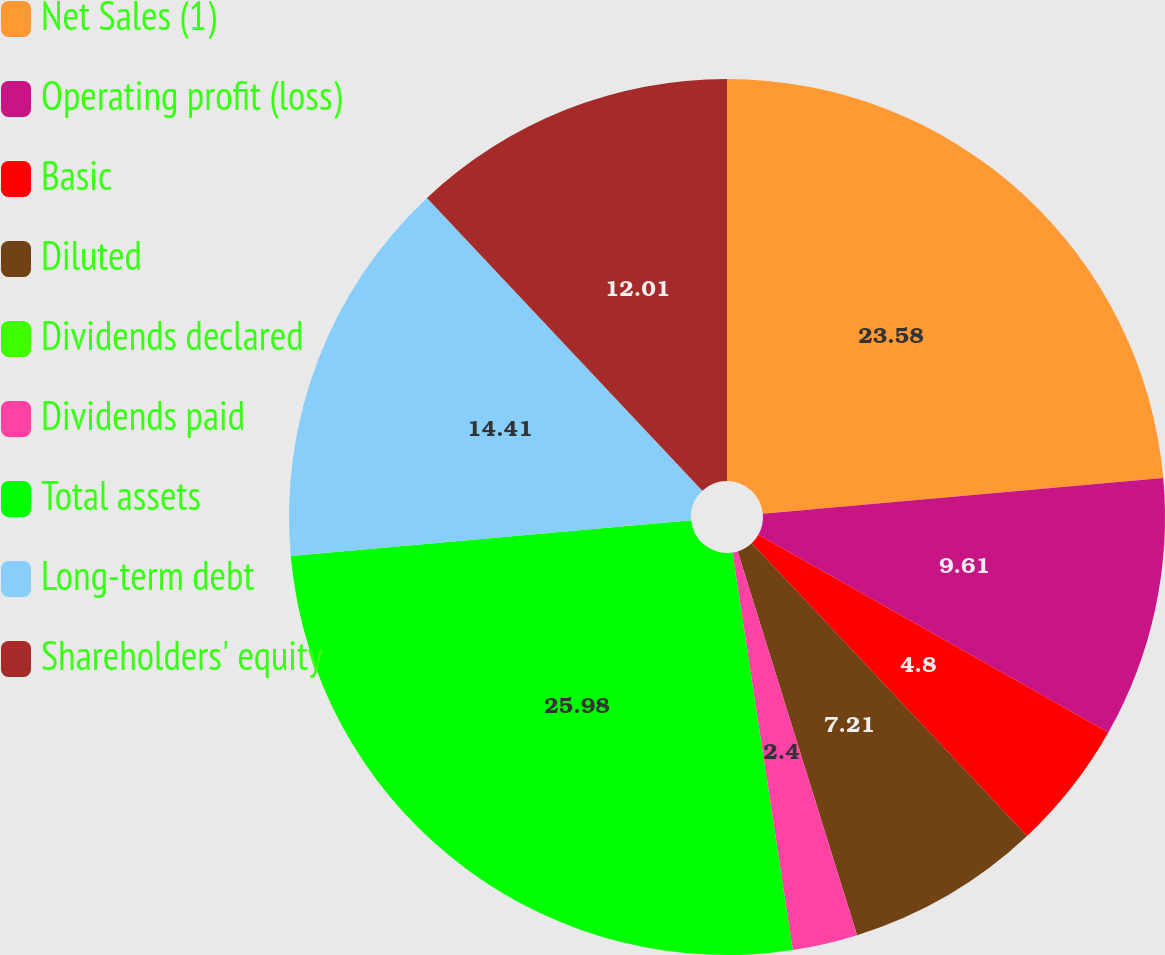Convert chart to OTSL. <chart><loc_0><loc_0><loc_500><loc_500><pie_chart><fcel>Net Sales (1)<fcel>Operating profit (loss)<fcel>Basic<fcel>Diluted<fcel>Dividends declared<fcel>Dividends paid<fcel>Total assets<fcel>Long-term debt<fcel>Shareholders' equity<nl><fcel>23.58%<fcel>9.61%<fcel>4.8%<fcel>7.21%<fcel>0.0%<fcel>2.4%<fcel>25.98%<fcel>14.41%<fcel>12.01%<nl></chart> 